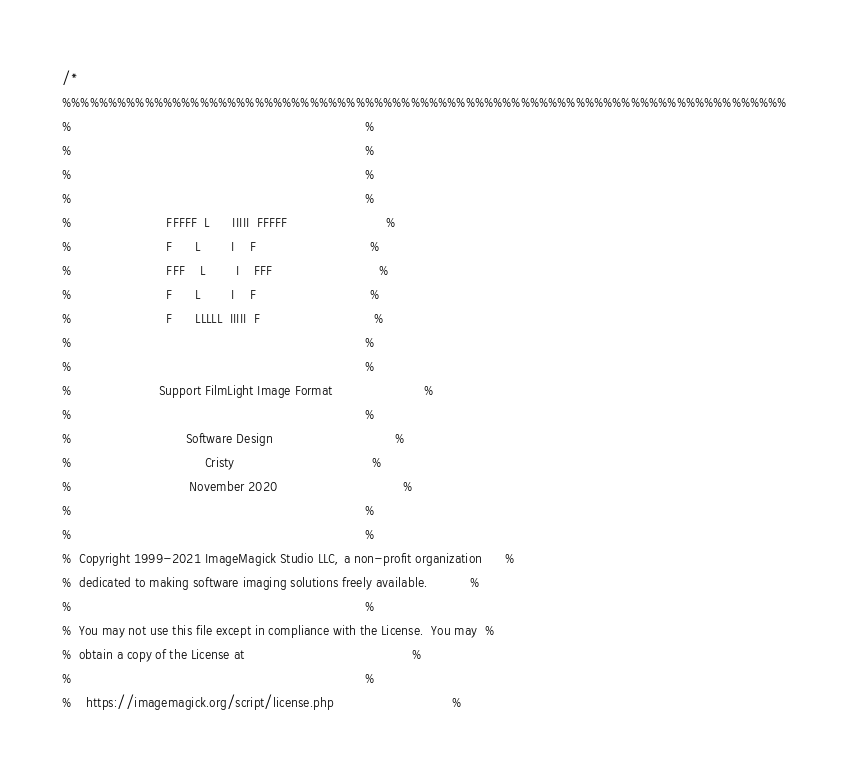<code> <loc_0><loc_0><loc_500><loc_500><_C_>/*
%%%%%%%%%%%%%%%%%%%%%%%%%%%%%%%%%%%%%%%%%%%%%%%%%%%%%%%%%%%%%%%%%%%%%%%%%%%%%%%
%                                                                             %
%                                                                             %
%                                                                             %
%                                                                             %
%                         FFFFF  L      IIIII  FFFFF                          %
%                         F      L        I    F                              %
%                         FFF    L        I    FFF                            %
%                         F      L        I    F                              %
%                         F      LLLLL  IIIII  F                              %
%                                                                             %
%                                                                             %
%                       Support FilmLight Image Format                        %
%                                                                             %
%                              Software Design                                %
%                                   Cristy                                    %
%                               November 2020                                 %
%                                                                             %
%                                                                             %
%  Copyright 1999-2021 ImageMagick Studio LLC, a non-profit organization      %
%  dedicated to making software imaging solutions freely available.           %
%                                                                             %
%  You may not use this file except in compliance with the License.  You may  %
%  obtain a copy of the License at                                            %
%                                                                             %
%    https://imagemagick.org/script/license.php                               %</code> 